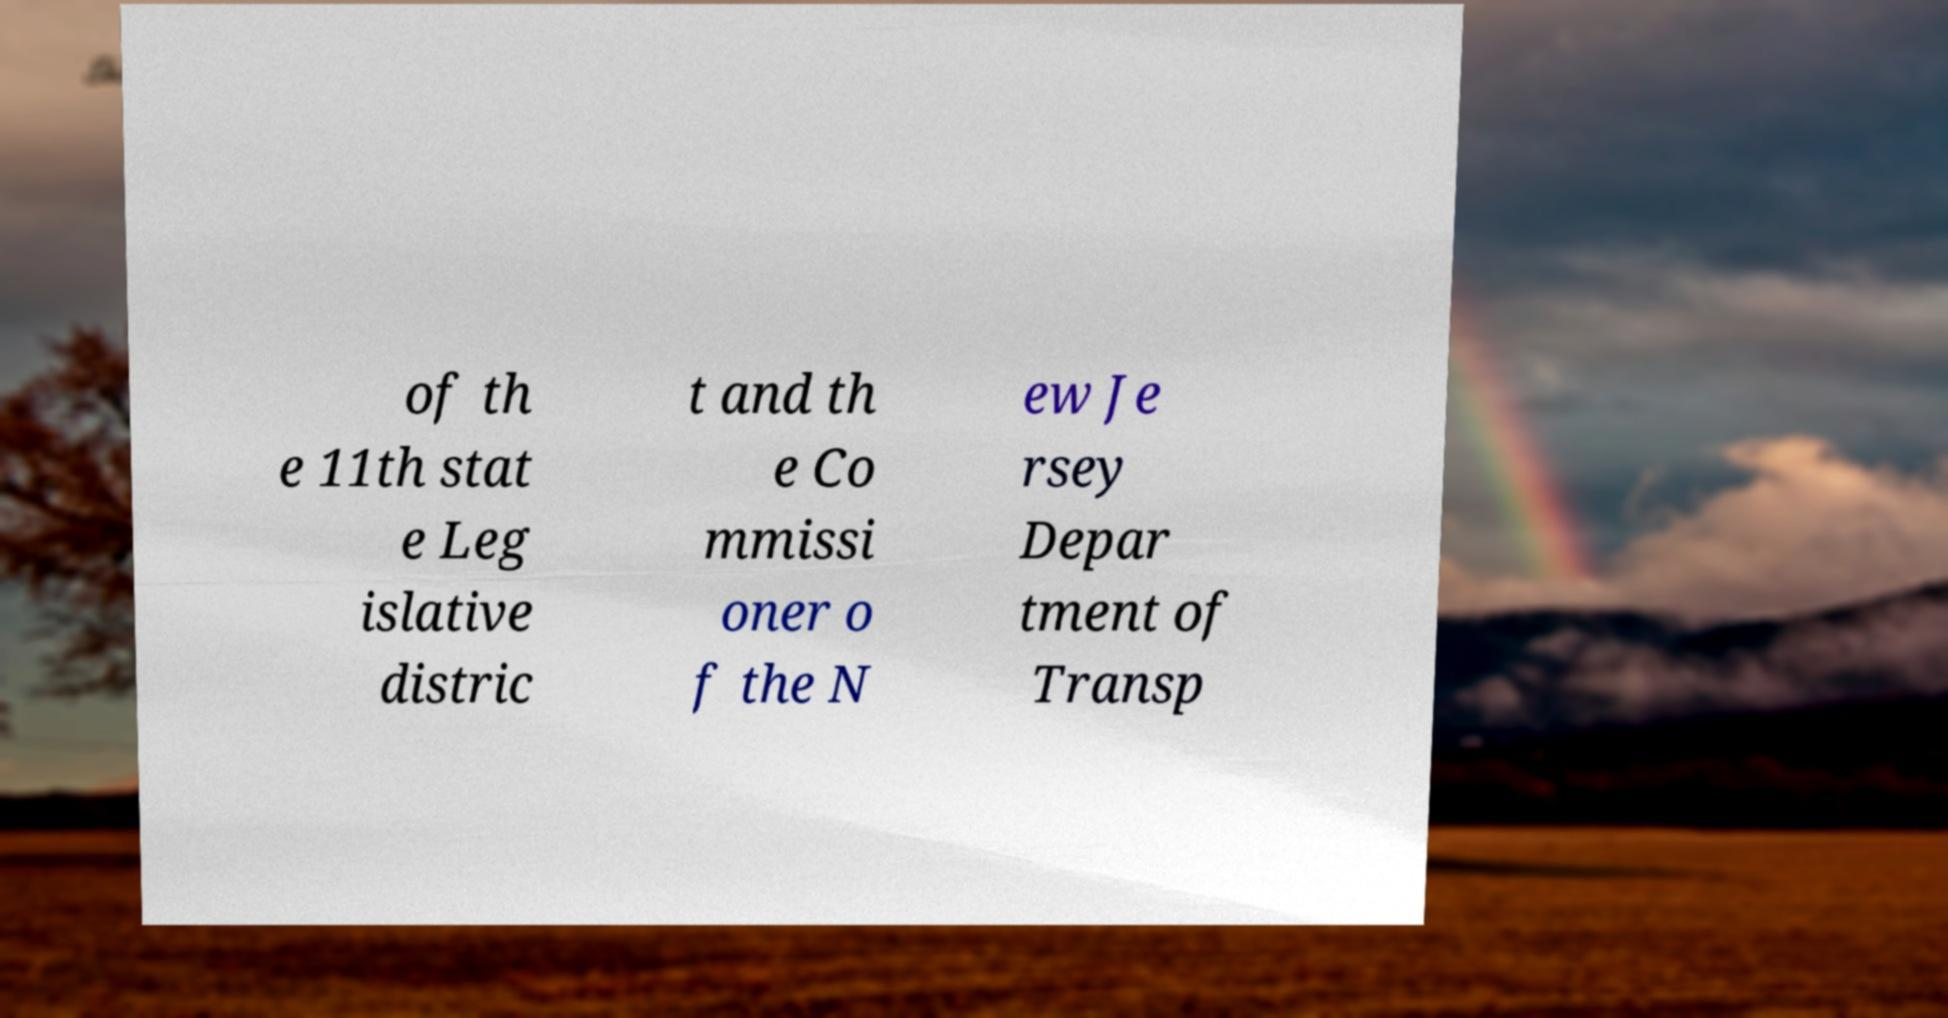Could you extract and type out the text from this image? of th e 11th stat e Leg islative distric t and th e Co mmissi oner o f the N ew Je rsey Depar tment of Transp 